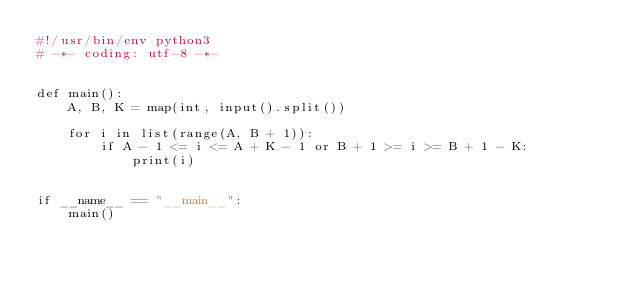Convert code to text. <code><loc_0><loc_0><loc_500><loc_500><_Python_>#!/usr/bin/env python3
# -*- coding: utf-8 -*-


def main():
    A, B, K = map(int, input().split())

    for i in list(range(A, B + 1)):
        if A - 1 <= i <= A + K - 1 or B + 1 >= i >= B + 1 - K:
            print(i)


if __name__ == "__main__":
    main()
</code> 